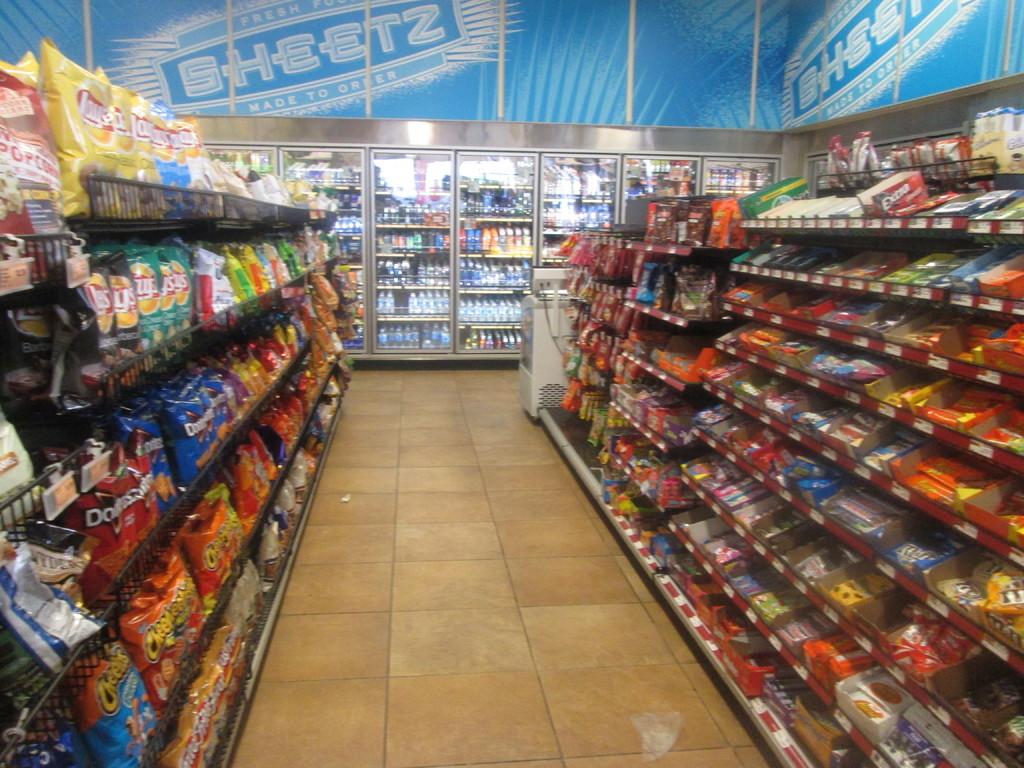Are items at sheetz pre-made?
Your answer should be compact. Yes. What is on the wall?
Give a very brief answer. Sheetz. 